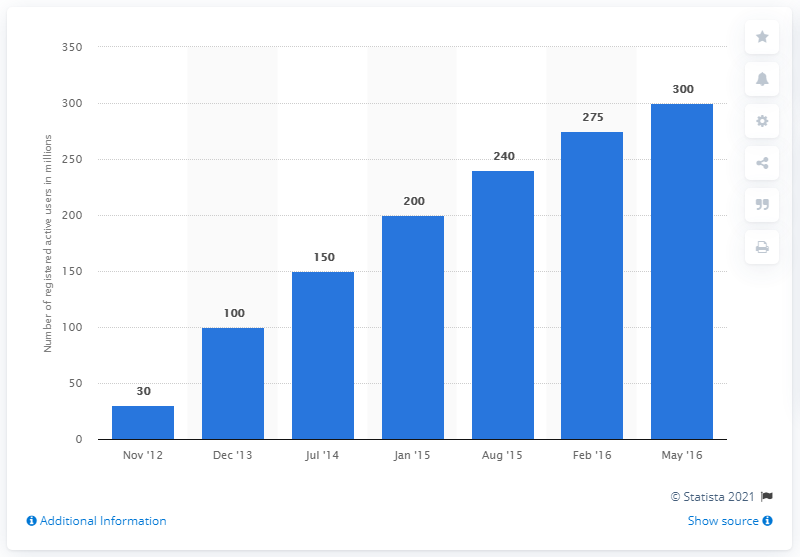Give some essential details in this illustration. In May 2016, Kik had approximately 300 registered users. In August of 2016, Kik had 240 registered users. 